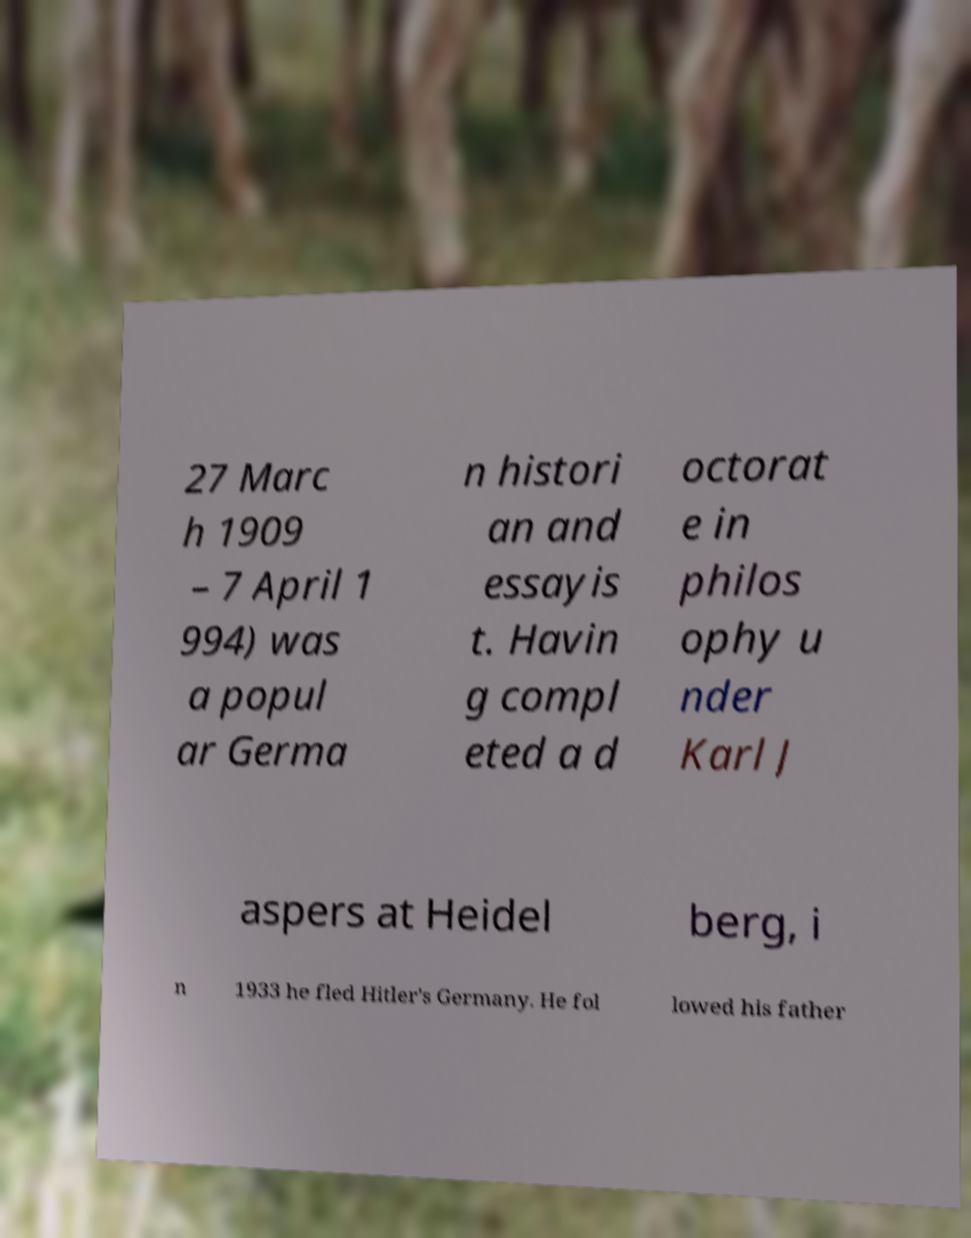I need the written content from this picture converted into text. Can you do that? 27 Marc h 1909 – 7 April 1 994) was a popul ar Germa n histori an and essayis t. Havin g compl eted a d octorat e in philos ophy u nder Karl J aspers at Heidel berg, i n 1933 he fled Hitler's Germany. He fol lowed his father 